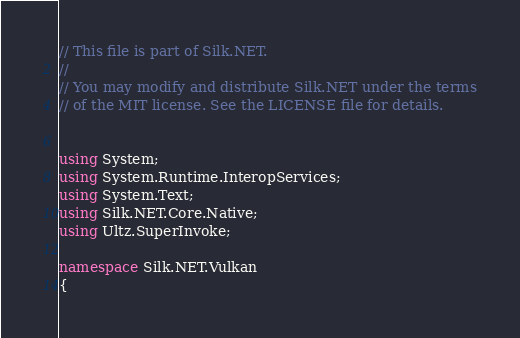Convert code to text. <code><loc_0><loc_0><loc_500><loc_500><_C#_>// This file is part of Silk.NET.
// 
// You may modify and distribute Silk.NET under the terms
// of the MIT license. See the LICENSE file for details.


using System;
using System.Runtime.InteropServices;
using System.Text;
using Silk.NET.Core.Native;
using Ultz.SuperInvoke;

namespace Silk.NET.Vulkan
{</code> 